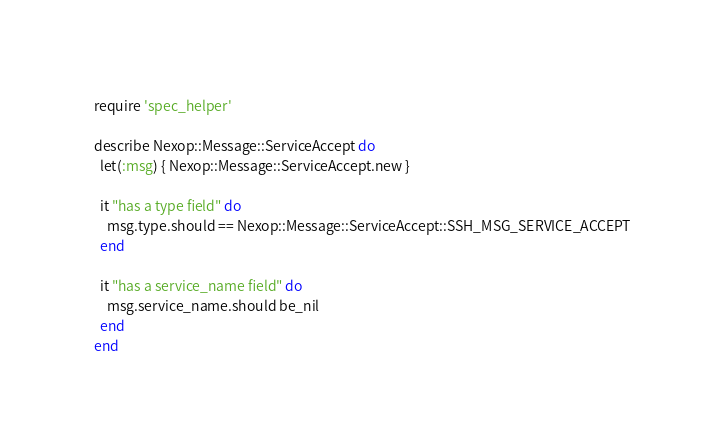Convert code to text. <code><loc_0><loc_0><loc_500><loc_500><_Ruby_>require 'spec_helper'

describe Nexop::Message::ServiceAccept do
  let(:msg) { Nexop::Message::ServiceAccept.new }

  it "has a type field" do
    msg.type.should == Nexop::Message::ServiceAccept::SSH_MSG_SERVICE_ACCEPT
  end

  it "has a service_name field" do
    msg.service_name.should be_nil
  end
end
</code> 